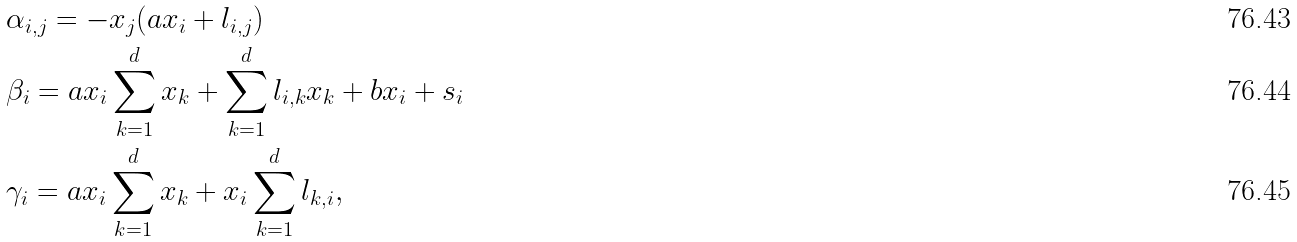Convert formula to latex. <formula><loc_0><loc_0><loc_500><loc_500>& \alpha _ { i , j } = - x _ { j } ( a x _ { i } + l _ { i , j } ) \\ & \beta _ { i } = a x _ { i } \sum _ { k = 1 } ^ { d } x _ { k } + \sum _ { k = 1 } ^ { d } l _ { i , k } x _ { k } + b x _ { i } + s _ { i } \\ & \gamma _ { i } = a x _ { i } \sum _ { k = 1 } ^ { d } x _ { k } + x _ { i } \sum _ { k = 1 } ^ { d } l _ { k , i } ,</formula> 